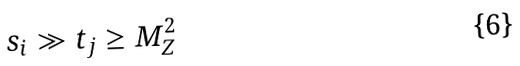<formula> <loc_0><loc_0><loc_500><loc_500>s _ { i } \gg t _ { j } \geq M ^ { 2 } _ { Z }</formula> 